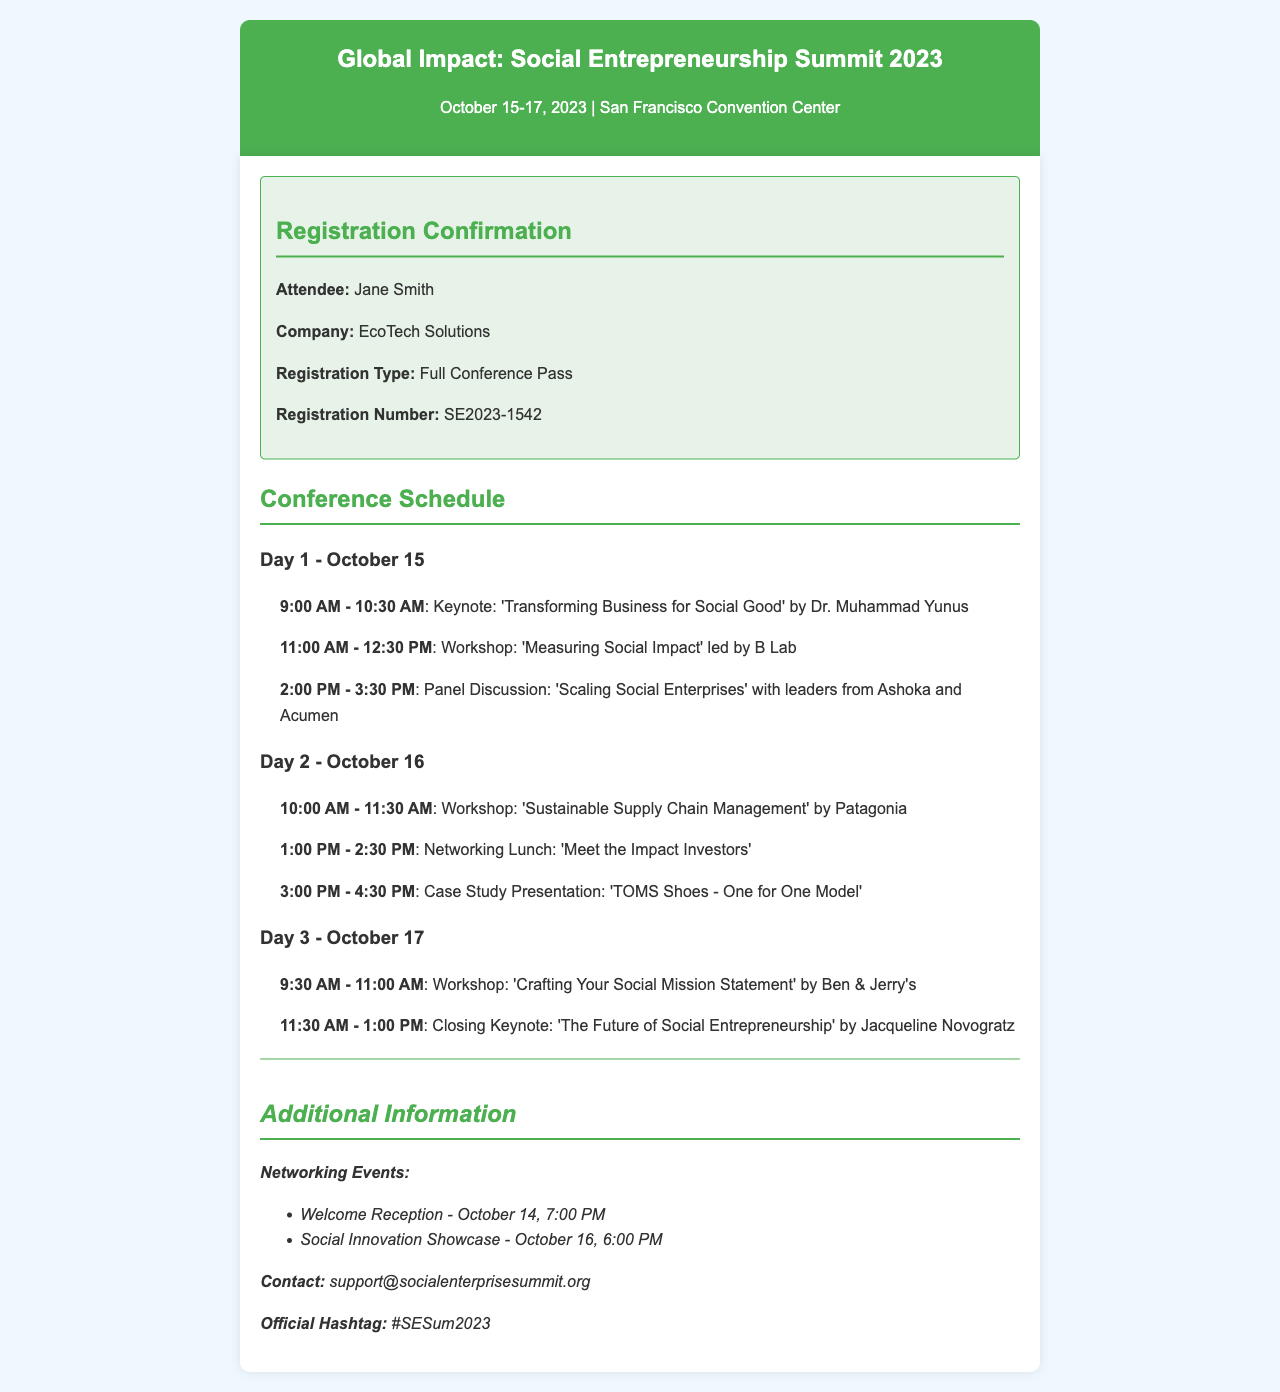What are the conference dates? The conference takes place from October 15 to October 17, 2023.
Answer: October 15-17, 2023 What is the keynote speaker's name for Day 1? The keynote speaker on Day 1 is Dr. Muhammad Yunus.
Answer: Dr. Muhammad Yunus What is the registration number? The registration number provided in the document is SE2023-1542.
Answer: SE2023-1542 Which company is Jane Smith associated with? Jane Smith's company mentioned in the document is EcoTech Solutions.
Answer: EcoTech Solutions What workshop is scheduled for October 16 at 10:00 AM? The workshop scheduled for October 16 at 10:00 AM is 'Sustainable Supply Chain Management' by Patagonia.
Answer: 'Sustainable Supply Chain Management' by Patagonia How many networking events are listed? There are two networking events mentioned in the document.
Answer: Two What is the official hashtag for the conference? The official hashtag provided is #SESum2023.
Answer: #SESum2023 What time is the Welcome Reception? The Welcome Reception is at 7:00 PM on October 14.
Answer: 7:00 PM What topic will the closing keynote cover? The closing keynote will cover 'The Future of Social Entrepreneurship.'
Answer: 'The Future of Social Entrepreneurship' 